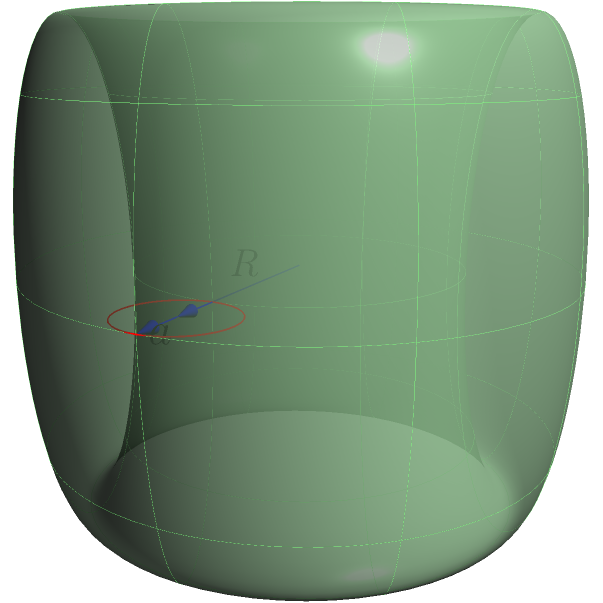In Indigenous art, circular motifs often represent unity and the cyclical nature of life. Consider a torus with a major radius $R = 2$ units and a minor radius $a = 0.5$ units, reminiscent of these circular motifs. Calculate the volume of this torus and explain how this mathematical concept might relate to the representation of continuity in Indigenous art. To calculate the volume of a torus, we'll follow these steps:

1) The formula for the volume of a torus is:

   $$V = 2\pi^2 R a^2$$

   Where $R$ is the major radius (distance from the center of the tube to the center of the torus) and $a$ is the minor radius (radius of the tube).

2) We're given:
   $R = 2$ units
   $a = 0.5$ units

3) Let's substitute these values into the formula:

   $$V = 2\pi^2 \cdot 2 \cdot (0.5)^2$$

4) Simplify:
   $$V = 2\pi^2 \cdot 2 \cdot 0.25$$
   $$V = \pi^2$$

5) This gives us the exact volume in terms of $\pi^2$. If we want a numerical approximation:
   $$V \approx 9.8696 \text{ cubic units}$$

Relating to Indigenous art:
The torus shape, with its continuous surface and lack of beginning or end, can be seen as a three-dimensional representation of circular motifs in Indigenous art. These motifs often symbolize the continuity of life, seasons, and cultural practices. The volume we calculated represents the 'substance' of this continuity, emphasizing the depth and significance of these cultural concepts. Just as the torus volume is derived from both its major and minor radii, Indigenous circular motifs often contain layers of meaning, combining broader cultural narratives (represented by the major radius) with specific symbolic details (represented by the minor radius).
Answer: $\pi^2$ cubic units 